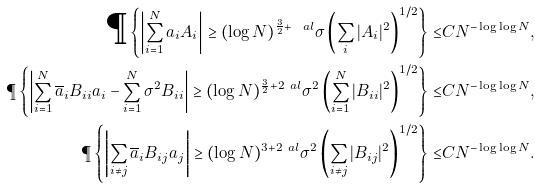Convert formula to latex. <formula><loc_0><loc_0><loc_500><loc_500>\P \left \{ \left | \sum _ { i = 1 } ^ { N } a _ { i } A _ { i } \right | \geq ( \log N ) ^ { \frac { 3 } { 2 } + \ a l } \sigma \left ( \sum _ { i } | A _ { i } | ^ { 2 } \right ) ^ { 1 / 2 } \right \} \leq & C N ^ { - \log \log N } , \\ \P \left \{ \left | \sum _ { i = 1 } ^ { N } \overline { a } _ { i } B _ { i i } a _ { i } - \sum _ { i = 1 } ^ { N } \sigma ^ { 2 } B _ { i i } \right | \geq ( \log N ) ^ { \frac { 3 } { 2 } + 2 \ a l } \sigma ^ { 2 } \left ( \sum _ { i = 1 } ^ { N } | B _ { i i } | ^ { 2 } \right ) ^ { 1 / 2 } \right \} \leq & C N ^ { - \log \log N } , \\ \P \left \{ \left | \sum _ { i \neq j } \overline { a } _ { i } B _ { i j } a _ { j } \right | \geq ( \log N ) ^ { 3 + 2 \ a l } \sigma ^ { 2 } \left ( \sum _ { i \ne j } | B _ { i j } | ^ { 2 } \right ) ^ { 1 / 2 } \right \} \leq & C N ^ { - \log \log N } .</formula> 